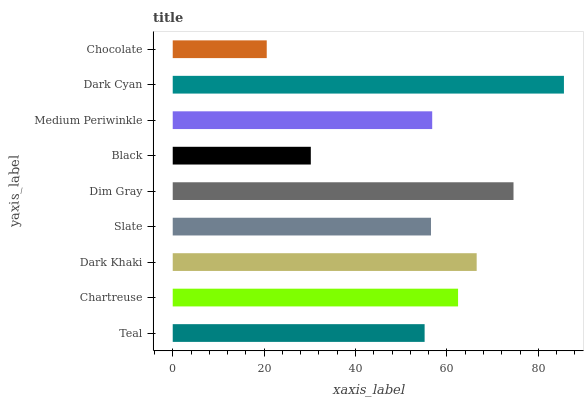Is Chocolate the minimum?
Answer yes or no. Yes. Is Dark Cyan the maximum?
Answer yes or no. Yes. Is Chartreuse the minimum?
Answer yes or no. No. Is Chartreuse the maximum?
Answer yes or no. No. Is Chartreuse greater than Teal?
Answer yes or no. Yes. Is Teal less than Chartreuse?
Answer yes or no. Yes. Is Teal greater than Chartreuse?
Answer yes or no. No. Is Chartreuse less than Teal?
Answer yes or no. No. Is Medium Periwinkle the high median?
Answer yes or no. Yes. Is Medium Periwinkle the low median?
Answer yes or no. Yes. Is Dim Gray the high median?
Answer yes or no. No. Is Chartreuse the low median?
Answer yes or no. No. 